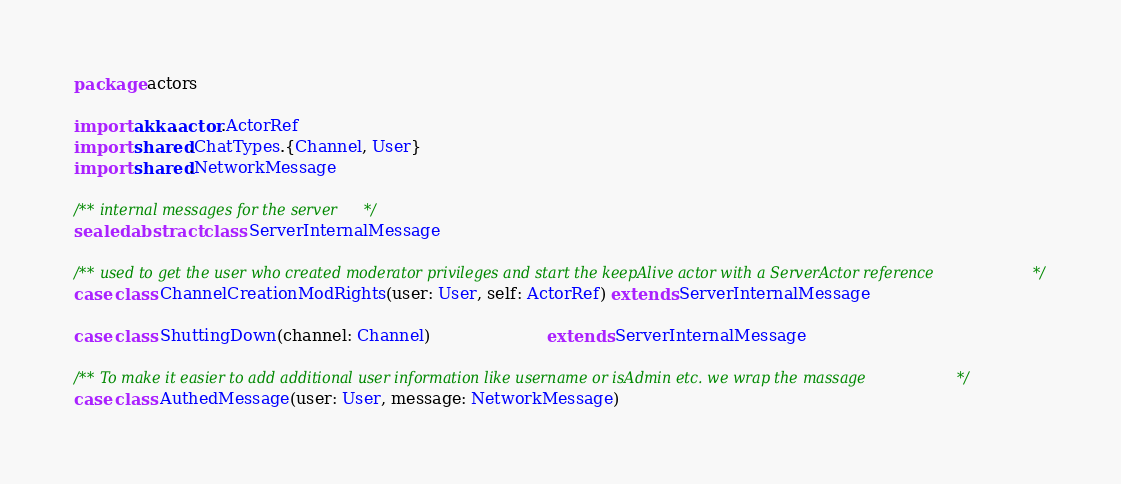Convert code to text. <code><loc_0><loc_0><loc_500><loc_500><_Scala_>package actors

import akka.actor.ActorRef
import shared.ChatTypes.{Channel, User}
import shared.NetworkMessage

/** internal messages for the server*/
sealed abstract class ServerInternalMessage

/** used to get the user who created moderator privileges and start the keepAlive actor with a ServerActor reference */
case class ChannelCreationModRights(user: User, self: ActorRef) extends ServerInternalMessage

case class ShuttingDown(channel: Channel)                       extends ServerInternalMessage

/** To make it easier to add additional user information like username or isAdmin etc. we wrap the massage */
case class AuthedMessage(user: User, message: NetworkMessage)
</code> 